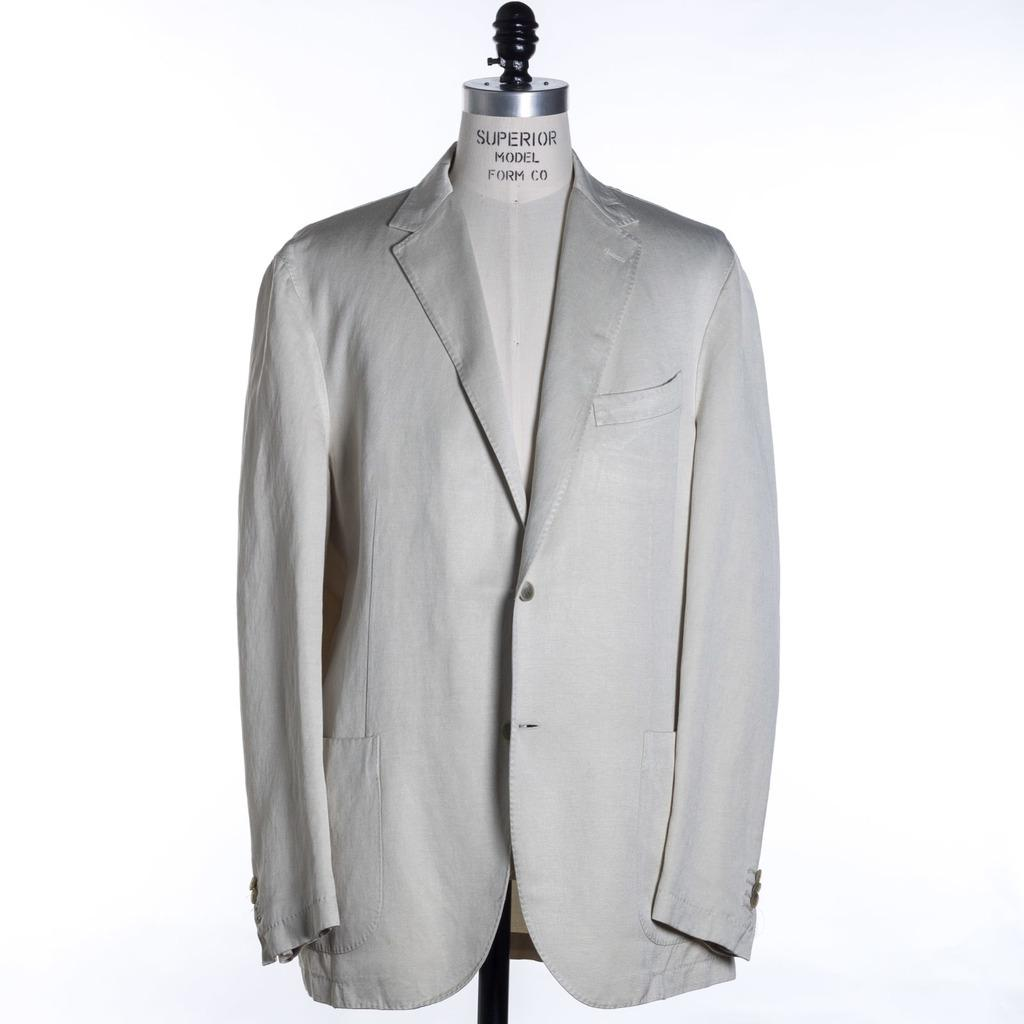What type of clothing item is in the image? There is a coat in the image. Where is the coat placed in the image? The coat is on a mannequin. Can you describe the positioning of the mannequin in the image? The mannequin is in the center of the image. What type of beast is paying attention to the coat in the image? There is no beast present in the image, and the coat is on a mannequin, not an animal. 